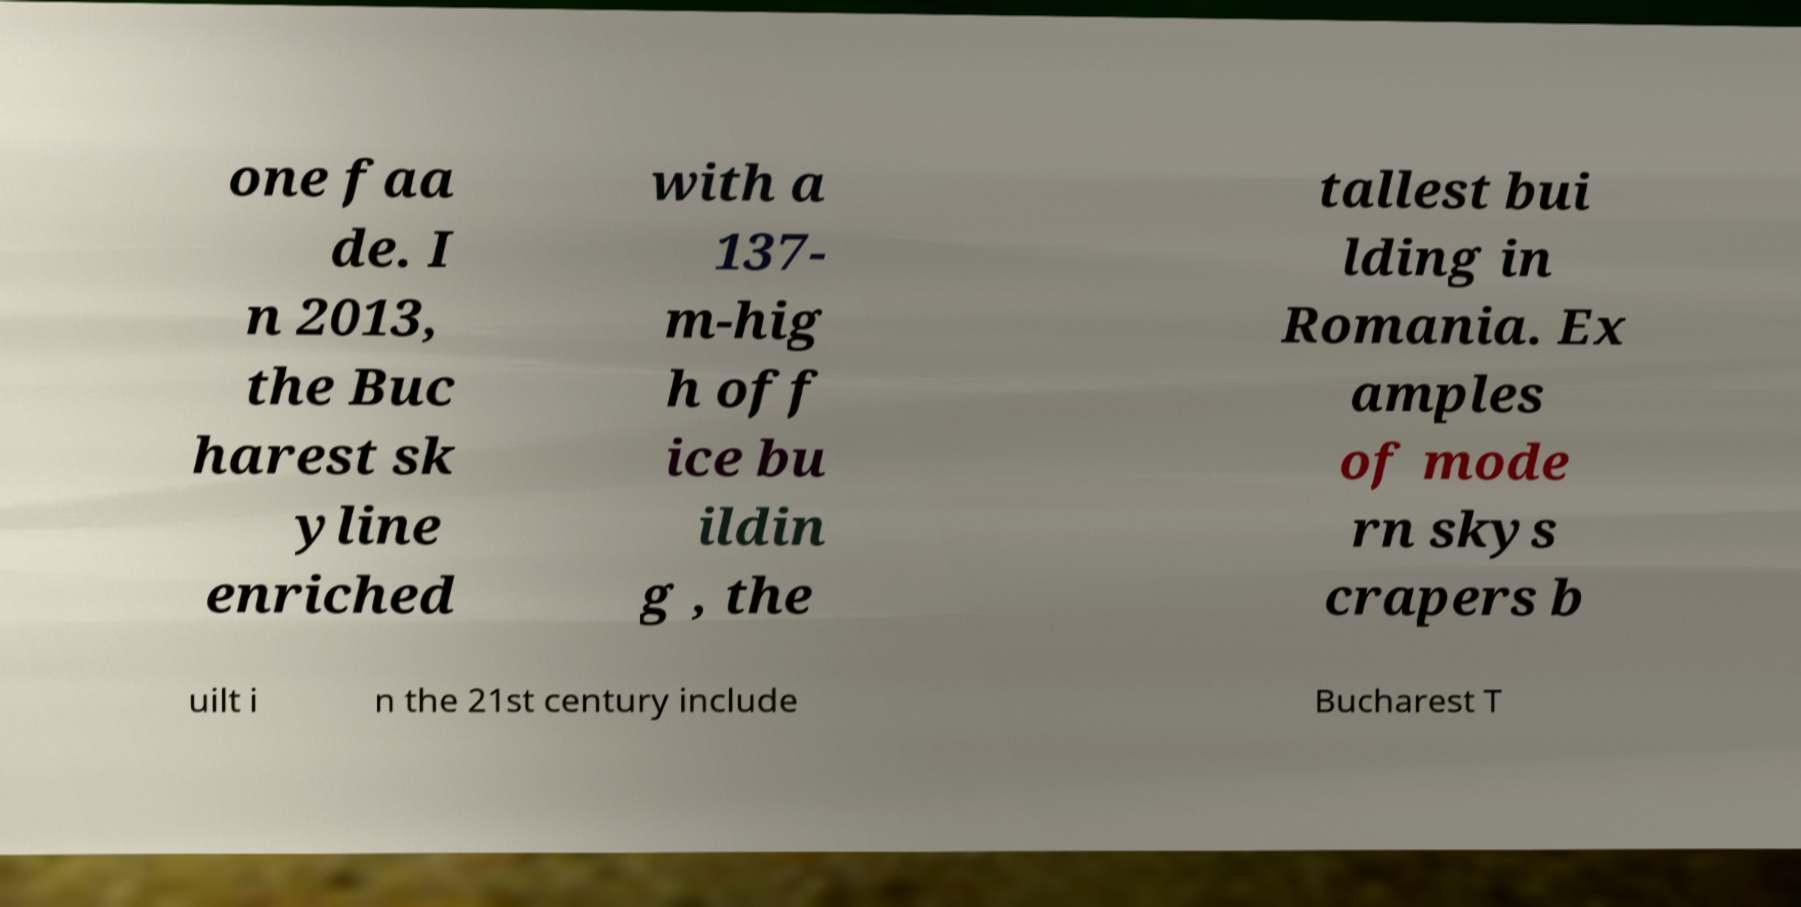I need the written content from this picture converted into text. Can you do that? one faa de. I n 2013, the Buc harest sk yline enriched with a 137- m-hig h off ice bu ildin g , the tallest bui lding in Romania. Ex amples of mode rn skys crapers b uilt i n the 21st century include Bucharest T 